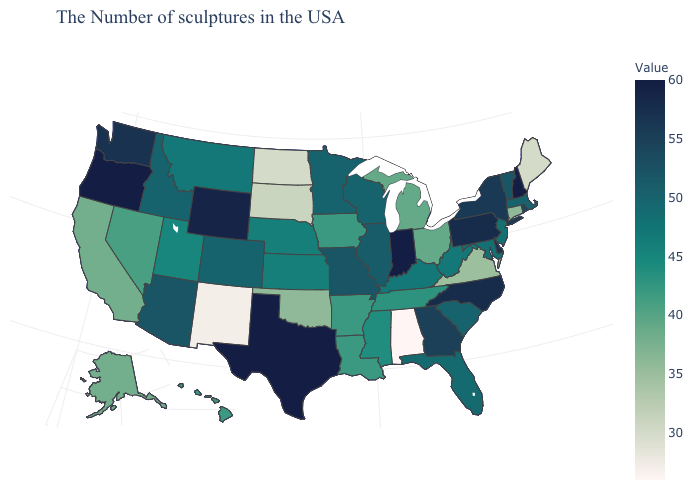Does Indiana have the highest value in the MidWest?
Be succinct. Yes. Does Iowa have the highest value in the USA?
Keep it brief. No. Which states hav the highest value in the MidWest?
Write a very short answer. Indiana. Which states hav the highest value in the South?
Give a very brief answer. Texas. Does Virginia have a higher value than North Dakota?
Write a very short answer. Yes. Which states hav the highest value in the West?
Concise answer only. Oregon. Does Maine have the lowest value in the Northeast?
Keep it brief. Yes. Does Pennsylvania have the lowest value in the USA?
Be succinct. No. 